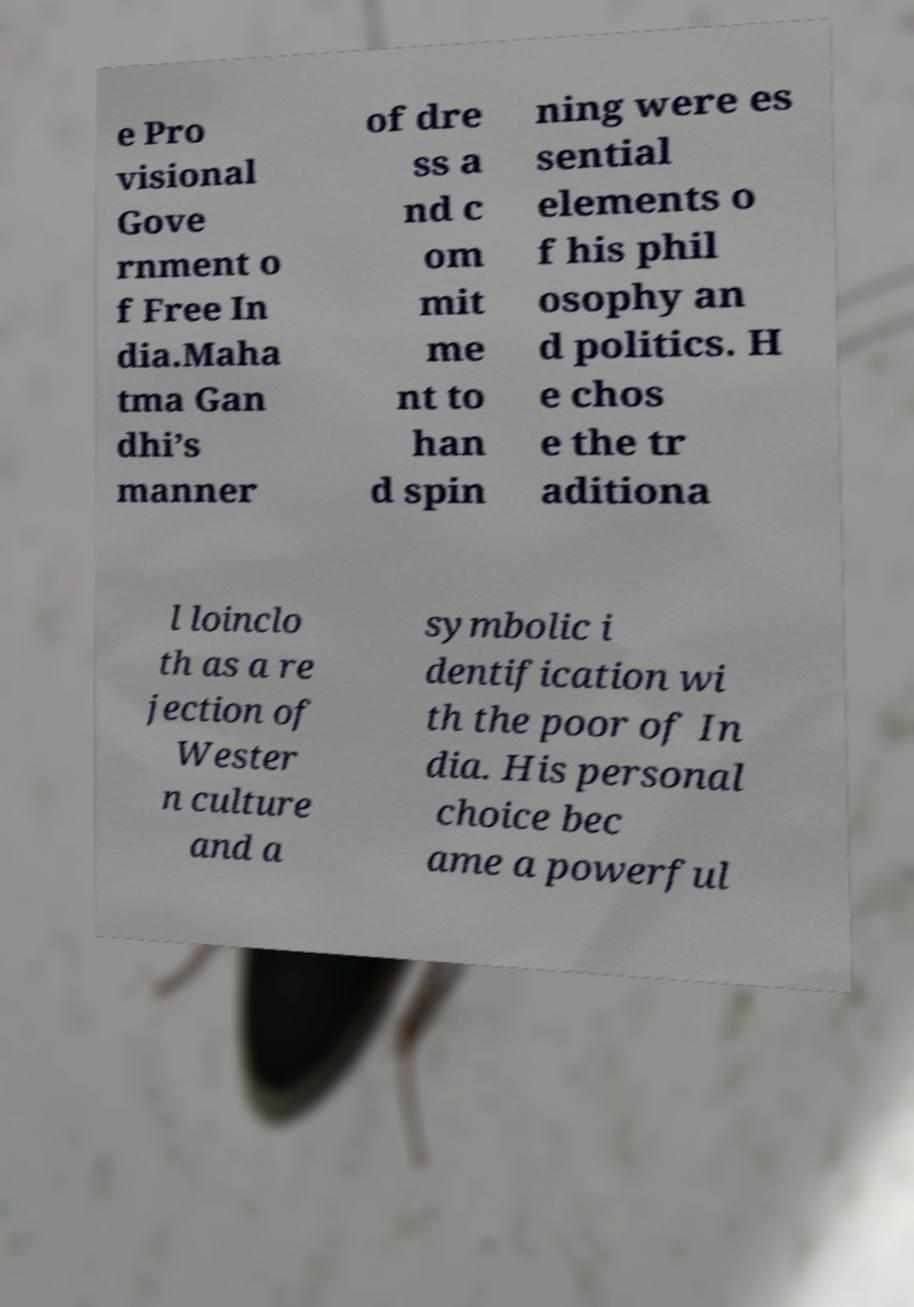What messages or text are displayed in this image? I need them in a readable, typed format. e Pro visional Gove rnment o f Free In dia.Maha tma Gan dhi’s manner of dre ss a nd c om mit me nt to han d spin ning were es sential elements o f his phil osophy an d politics. H e chos e the tr aditiona l loinclo th as a re jection of Wester n culture and a symbolic i dentification wi th the poor of In dia. His personal choice bec ame a powerful 